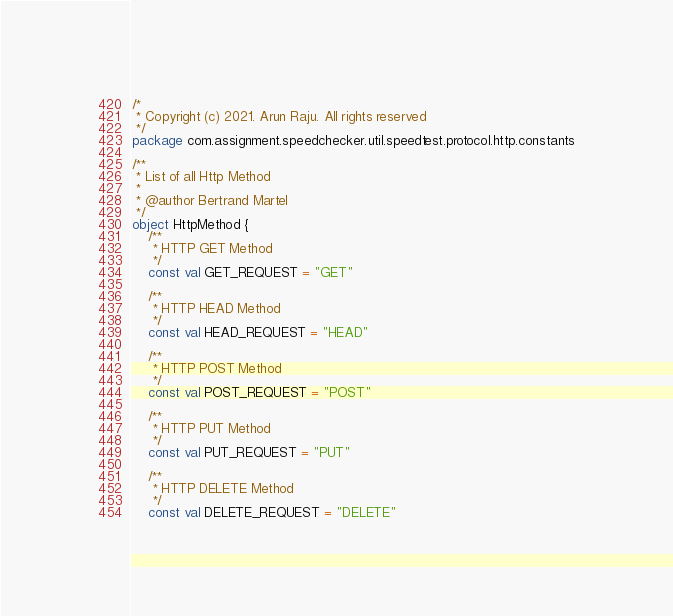Convert code to text. <code><loc_0><loc_0><loc_500><loc_500><_Kotlin_>/*
 * Copyright (c) 2021. Arun Raju. All rights reserved
 */
package com.assignment.speedchecker.util.speedtest.protocol.http.constants

/**
 * List of all Http Method
 *
 * @author Bertrand Martel
 */
object HttpMethod {
    /**
     * HTTP GET Method
     */
    const val GET_REQUEST = "GET"

    /**
     * HTTP HEAD Method
     */
    const val HEAD_REQUEST = "HEAD"

    /**
     * HTTP POST Method
     */
    const val POST_REQUEST = "POST"

    /**
     * HTTP PUT Method
     */
    const val PUT_REQUEST = "PUT"

    /**
     * HTTP DELETE Method
     */
    const val DELETE_REQUEST = "DELETE"
</code> 